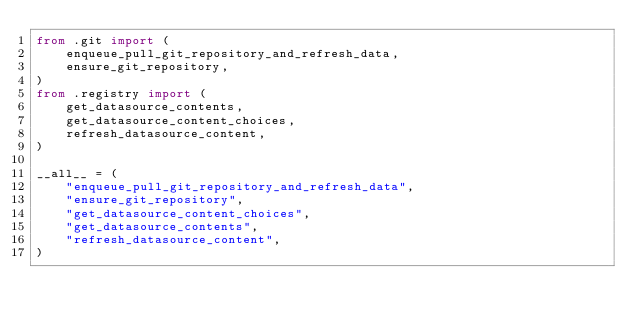<code> <loc_0><loc_0><loc_500><loc_500><_Python_>from .git import (
    enqueue_pull_git_repository_and_refresh_data,
    ensure_git_repository,
)
from .registry import (
    get_datasource_contents,
    get_datasource_content_choices,
    refresh_datasource_content,
)

__all__ = (
    "enqueue_pull_git_repository_and_refresh_data",
    "ensure_git_repository",
    "get_datasource_content_choices",
    "get_datasource_contents",
    "refresh_datasource_content",
)
</code> 